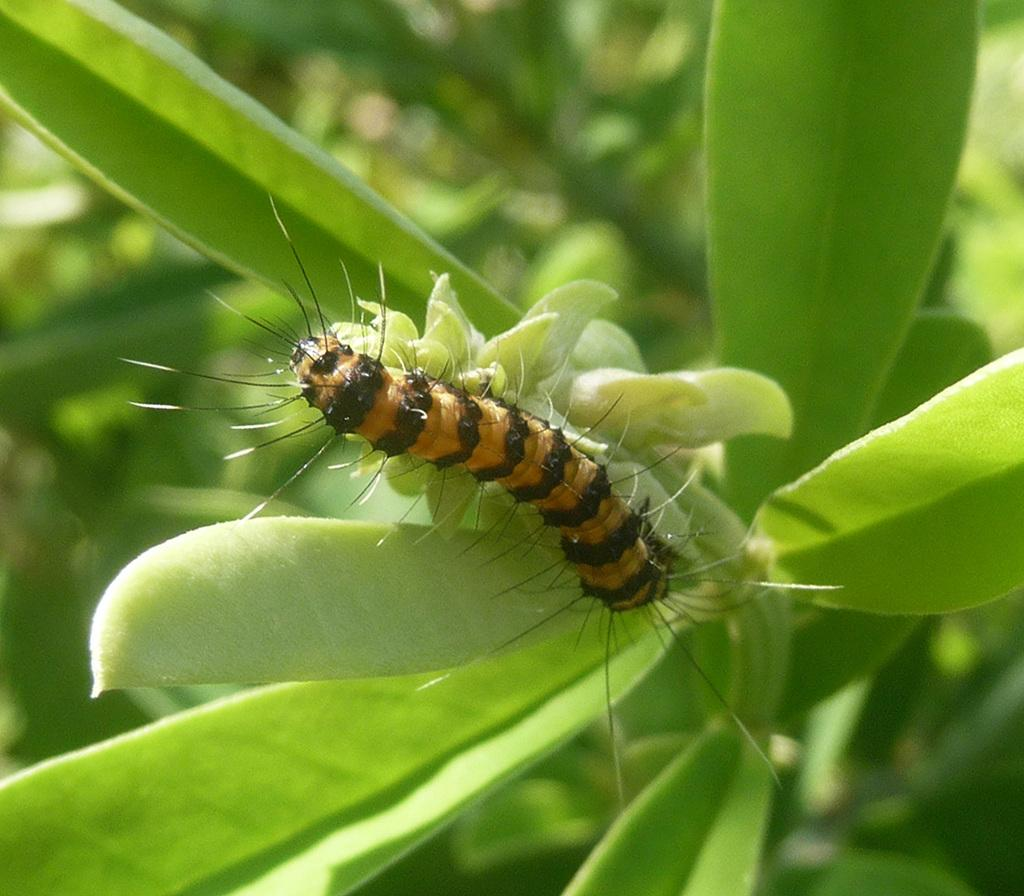What type of creature is present in the image? There is an insect in the image. Where is the insect located? The insect is on a plant. Can you describe the background of the image? The background of the image is blurry. What type of fruit is hanging from the plant in the image? There is no fruit visible in the image; only an insect on a plant is present. 